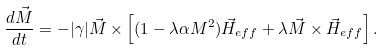<formula> <loc_0><loc_0><loc_500><loc_500>\frac { d \vec { M } } { d t } = - | { \gamma } | \vec { M } \times \left [ ( 1 - { \lambda } { \alpha } M ^ { 2 } ) \vec { H } _ { e f f } + { \lambda } \vec { M } \times \vec { H } _ { e f f } \right ] .</formula> 